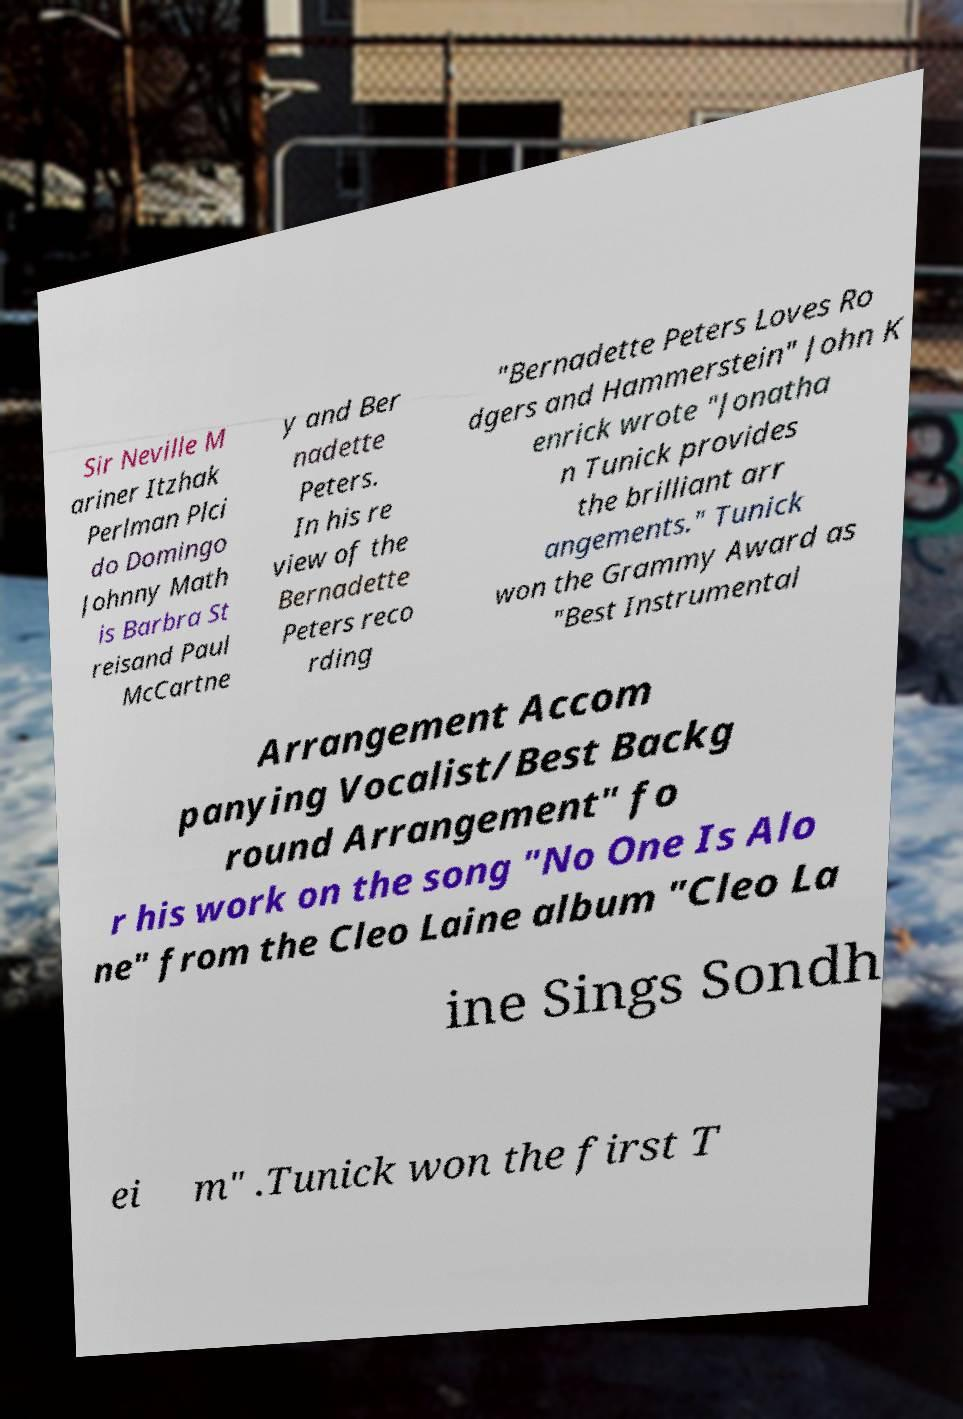Please read and relay the text visible in this image. What does it say? Sir Neville M ariner Itzhak Perlman Plci do Domingo Johnny Math is Barbra St reisand Paul McCartne y and Ber nadette Peters. In his re view of the Bernadette Peters reco rding "Bernadette Peters Loves Ro dgers and Hammerstein" John K enrick wrote "Jonatha n Tunick provides the brilliant arr angements." Tunick won the Grammy Award as "Best Instrumental Arrangement Accom panying Vocalist/Best Backg round Arrangement" fo r his work on the song "No One Is Alo ne" from the Cleo Laine album "Cleo La ine Sings Sondh ei m" .Tunick won the first T 